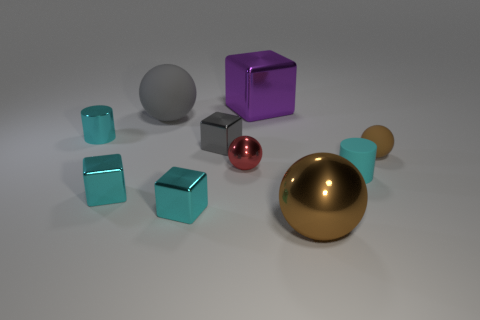This image looks like it could be a part of a physics puzzle. If I were to guess which object is the heaviest, which one should I pick? Based on their appearance, the large gold sphere might be the heaviest object due to its size and metallic sheen that suggests it's made of a dense material. However, without concrete information about the materials, it's purely speculative. If I wanted to use the purple cube as a container, which objects would fit inside? Assuming that the purple cube is hollow, the smaller red and gray spheres as well as the smallest cyan cubes could potentially fit inside, given their relative sizes. 